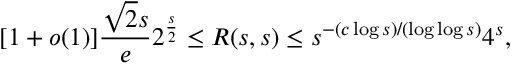Convert formula to latex. <formula><loc_0><loc_0><loc_500><loc_500>[ 1 + o ( 1 ) ] { \frac { { \sqrt { 2 } } s } { e } } 2 ^ { \frac { s } { 2 } } \leq R ( s , s ) \leq s ^ { - ( c \log s ) / ( \log \log s ) } 4 ^ { s } ,</formula> 